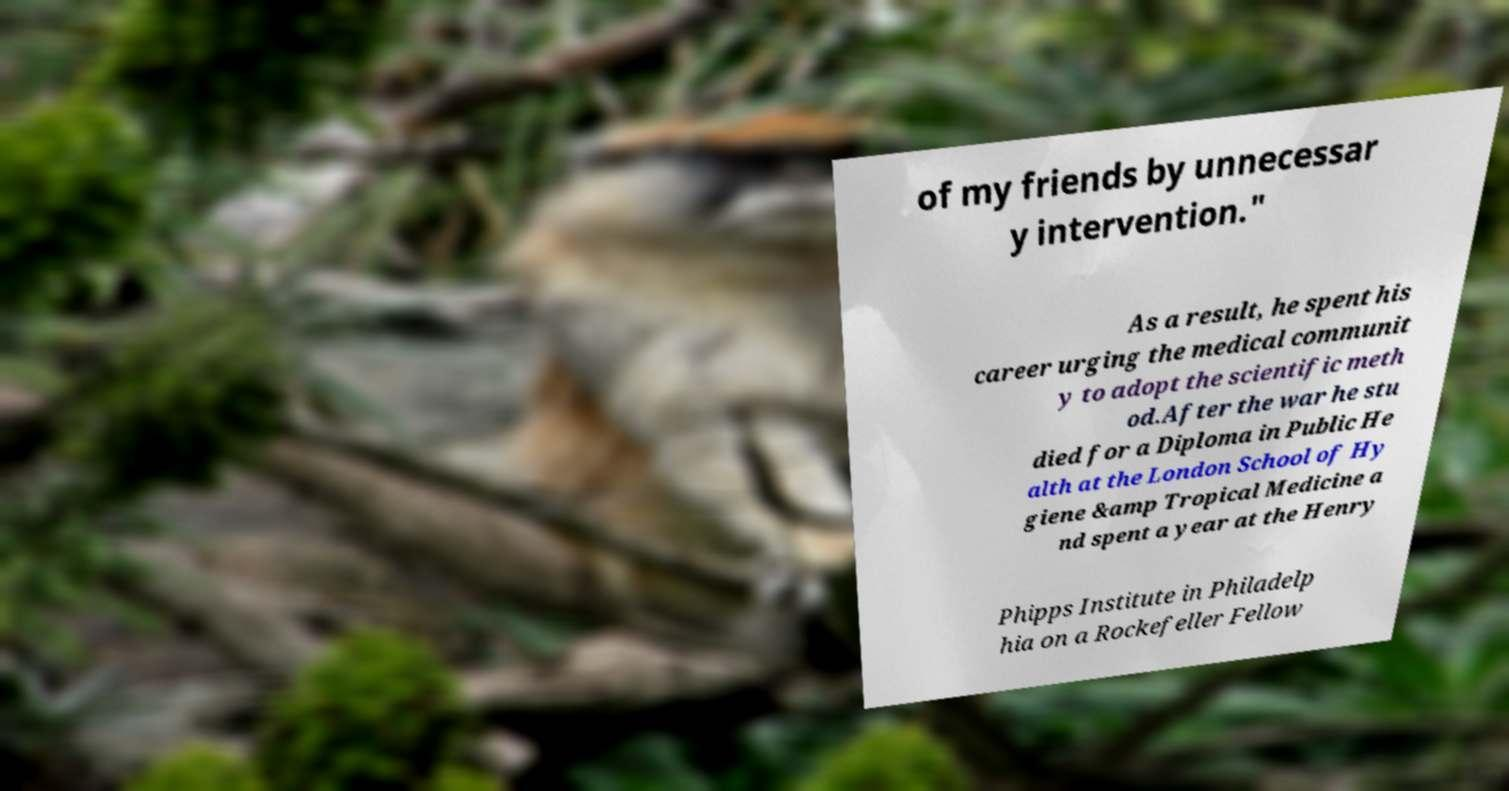I need the written content from this picture converted into text. Can you do that? of my friends by unnecessar y intervention." As a result, he spent his career urging the medical communit y to adopt the scientific meth od.After the war he stu died for a Diploma in Public He alth at the London School of Hy giene &amp Tropical Medicine a nd spent a year at the Henry Phipps Institute in Philadelp hia on a Rockefeller Fellow 